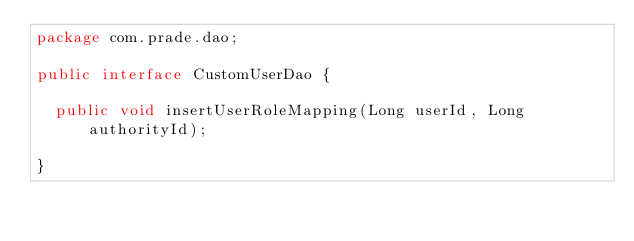Convert code to text. <code><loc_0><loc_0><loc_500><loc_500><_Java_>package com.prade.dao;

public interface CustomUserDao {
	
	public void insertUserRoleMapping(Long userId, Long authorityId);

}
</code> 